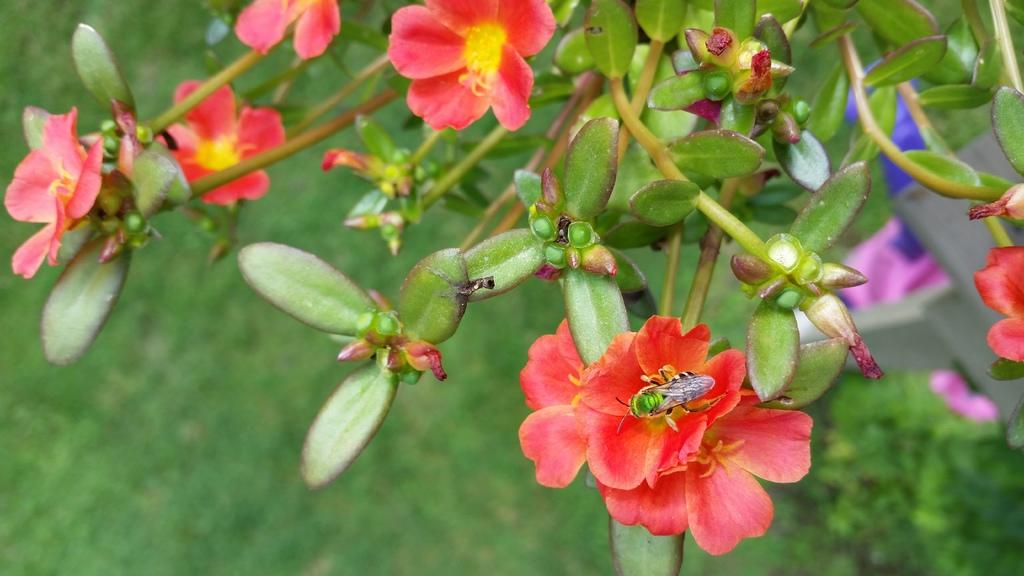What type of living organisms can be seen in the image? There are flowers, buds, and an insect in the image. What stage of growth are the flowers in? The flowers have buds, indicating that they are in the early stages of growth. What else is present in the image besides living organisms? There are plants in the image. How would you describe the background of the image? The background of the image is blurred. What grade did the insect receive on its recent exam in the image? There is no indication in the image that the insect has taken an exam or received a grade. 